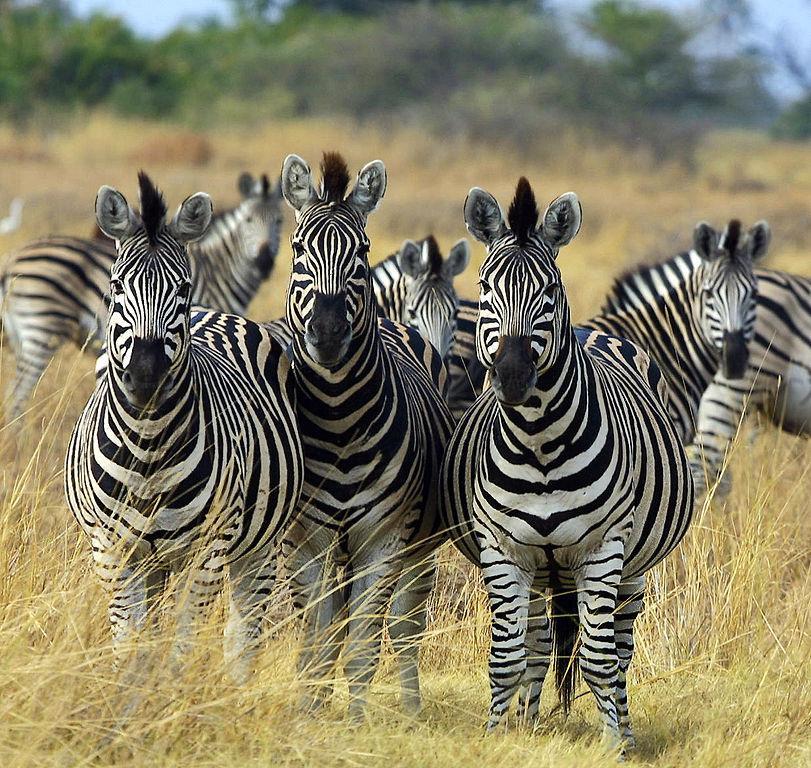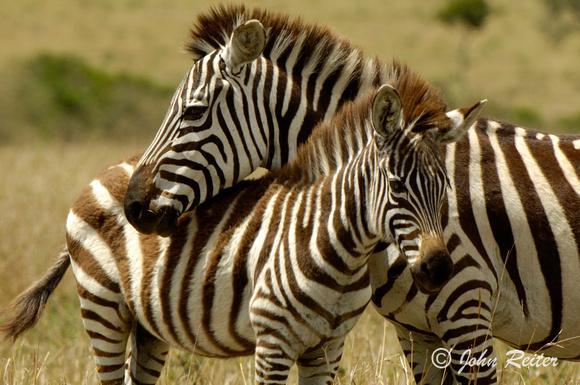The first image is the image on the left, the second image is the image on the right. Assess this claim about the two images: "There are three zebras standing side by side in a line and looking straight ahead in one of the images.". Correct or not? Answer yes or no. Yes. The first image is the image on the left, the second image is the image on the right. Considering the images on both sides, is "One image has a trio of zebras standing with bodies turned forward and gazing straight at the camera, in the foreground." valid? Answer yes or no. Yes. 